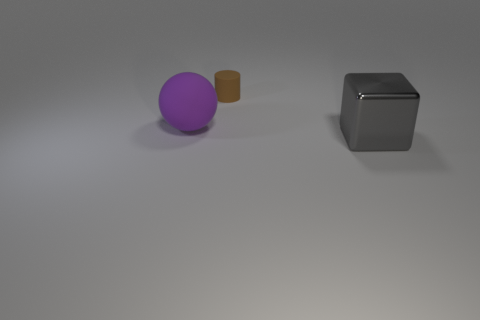Add 1 gray objects. How many objects exist? 4 Subtract all cubes. How many objects are left? 2 Subtract 1 purple spheres. How many objects are left? 2 Subtract all blue matte cylinders. Subtract all purple spheres. How many objects are left? 2 Add 2 big metal blocks. How many big metal blocks are left? 3 Add 2 small blue rubber spheres. How many small blue rubber spheres exist? 2 